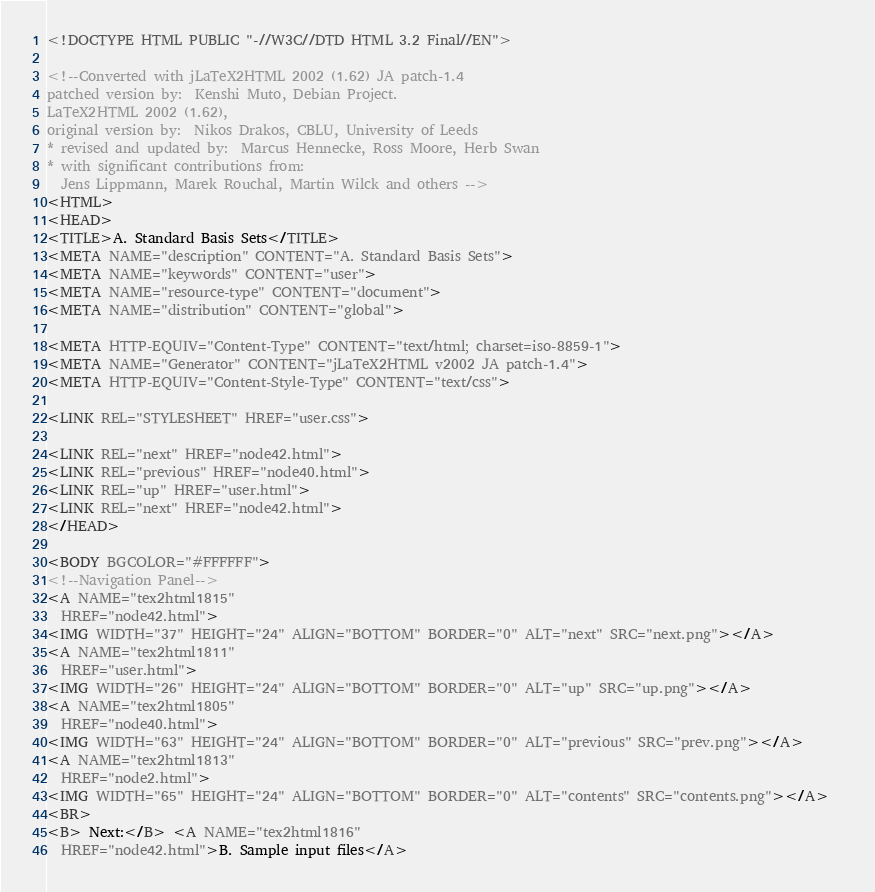<code> <loc_0><loc_0><loc_500><loc_500><_HTML_><!DOCTYPE HTML PUBLIC "-//W3C//DTD HTML 3.2 Final//EN">

<!--Converted with jLaTeX2HTML 2002 (1.62) JA patch-1.4
patched version by:  Kenshi Muto, Debian Project.
LaTeX2HTML 2002 (1.62),
original version by:  Nikos Drakos, CBLU, University of Leeds
* revised and updated by:  Marcus Hennecke, Ross Moore, Herb Swan
* with significant contributions from:
  Jens Lippmann, Marek Rouchal, Martin Wilck and others -->
<HTML>
<HEAD>
<TITLE>A. Standard Basis Sets</TITLE>
<META NAME="description" CONTENT="A. Standard Basis Sets">
<META NAME="keywords" CONTENT="user">
<META NAME="resource-type" CONTENT="document">
<META NAME="distribution" CONTENT="global">

<META HTTP-EQUIV="Content-Type" CONTENT="text/html; charset=iso-8859-1">
<META NAME="Generator" CONTENT="jLaTeX2HTML v2002 JA patch-1.4">
<META HTTP-EQUIV="Content-Style-Type" CONTENT="text/css">

<LINK REL="STYLESHEET" HREF="user.css">

<LINK REL="next" HREF="node42.html">
<LINK REL="previous" HREF="node40.html">
<LINK REL="up" HREF="user.html">
<LINK REL="next" HREF="node42.html">
</HEAD>

<BODY BGCOLOR="#FFFFFF">
<!--Navigation Panel-->
<A NAME="tex2html1815"
  HREF="node42.html">
<IMG WIDTH="37" HEIGHT="24" ALIGN="BOTTOM" BORDER="0" ALT="next" SRC="next.png"></A> 
<A NAME="tex2html1811"
  HREF="user.html">
<IMG WIDTH="26" HEIGHT="24" ALIGN="BOTTOM" BORDER="0" ALT="up" SRC="up.png"></A> 
<A NAME="tex2html1805"
  HREF="node40.html">
<IMG WIDTH="63" HEIGHT="24" ALIGN="BOTTOM" BORDER="0" ALT="previous" SRC="prev.png"></A> 
<A NAME="tex2html1813"
  HREF="node2.html">
<IMG WIDTH="65" HEIGHT="24" ALIGN="BOTTOM" BORDER="0" ALT="contents" SRC="contents.png"></A>  
<BR>
<B> Next:</B> <A NAME="tex2html1816"
  HREF="node42.html">B. Sample input files</A></code> 